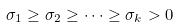<formula> <loc_0><loc_0><loc_500><loc_500>\sigma _ { 1 } \geq \sigma _ { 2 } \geq \dots \geq \sigma _ { k } > 0</formula> 